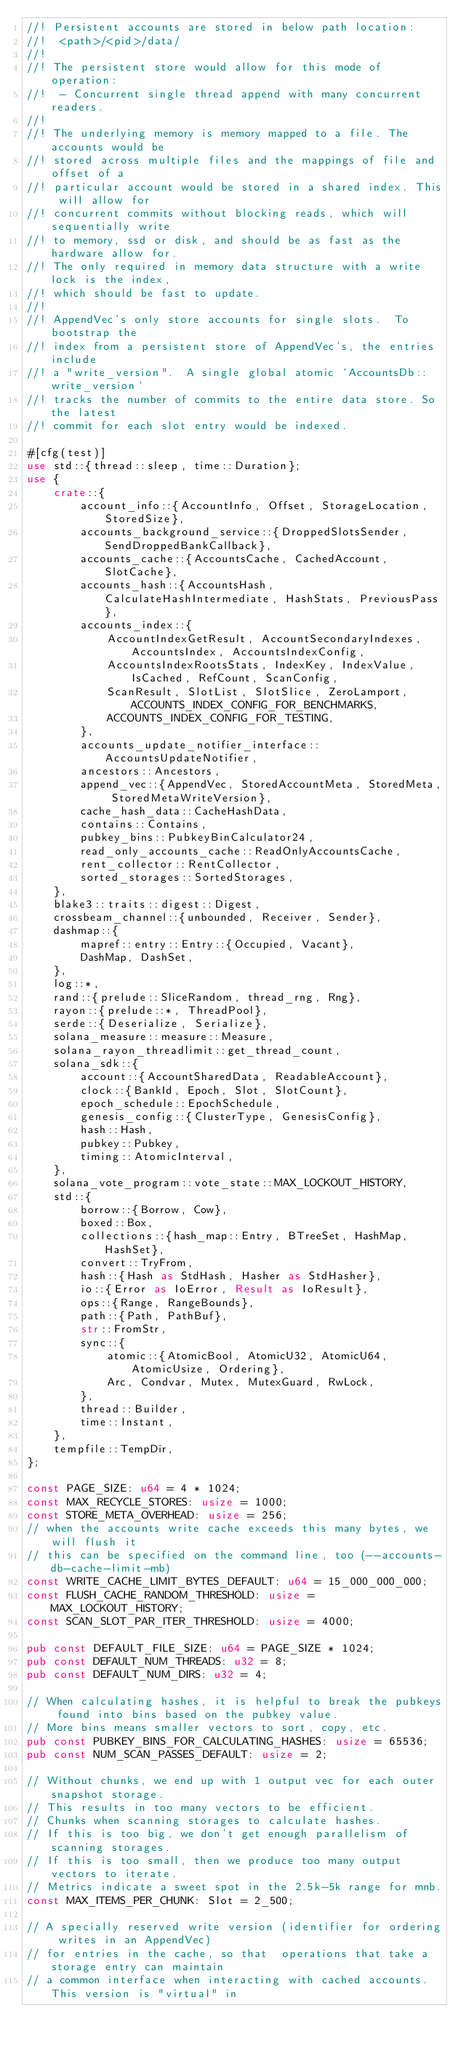<code> <loc_0><loc_0><loc_500><loc_500><_Rust_>//! Persistent accounts are stored in below path location:
//!  <path>/<pid>/data/
//!
//! The persistent store would allow for this mode of operation:
//!  - Concurrent single thread append with many concurrent readers.
//!
//! The underlying memory is memory mapped to a file. The accounts would be
//! stored across multiple files and the mappings of file and offset of a
//! particular account would be stored in a shared index. This will allow for
//! concurrent commits without blocking reads, which will sequentially write
//! to memory, ssd or disk, and should be as fast as the hardware allow for.
//! The only required in memory data structure with a write lock is the index,
//! which should be fast to update.
//!
//! AppendVec's only store accounts for single slots.  To bootstrap the
//! index from a persistent store of AppendVec's, the entries include
//! a "write_version".  A single global atomic `AccountsDb::write_version`
//! tracks the number of commits to the entire data store. So the latest
//! commit for each slot entry would be indexed.

#[cfg(test)]
use std::{thread::sleep, time::Duration};
use {
    crate::{
        account_info::{AccountInfo, Offset, StorageLocation, StoredSize},
        accounts_background_service::{DroppedSlotsSender, SendDroppedBankCallback},
        accounts_cache::{AccountsCache, CachedAccount, SlotCache},
        accounts_hash::{AccountsHash, CalculateHashIntermediate, HashStats, PreviousPass},
        accounts_index::{
            AccountIndexGetResult, AccountSecondaryIndexes, AccountsIndex, AccountsIndexConfig,
            AccountsIndexRootsStats, IndexKey, IndexValue, IsCached, RefCount, ScanConfig,
            ScanResult, SlotList, SlotSlice, ZeroLamport, ACCOUNTS_INDEX_CONFIG_FOR_BENCHMARKS,
            ACCOUNTS_INDEX_CONFIG_FOR_TESTING,
        },
        accounts_update_notifier_interface::AccountsUpdateNotifier,
        ancestors::Ancestors,
        append_vec::{AppendVec, StoredAccountMeta, StoredMeta, StoredMetaWriteVersion},
        cache_hash_data::CacheHashData,
        contains::Contains,
        pubkey_bins::PubkeyBinCalculator24,
        read_only_accounts_cache::ReadOnlyAccountsCache,
        rent_collector::RentCollector,
        sorted_storages::SortedStorages,
    },
    blake3::traits::digest::Digest,
    crossbeam_channel::{unbounded, Receiver, Sender},
    dashmap::{
        mapref::entry::Entry::{Occupied, Vacant},
        DashMap, DashSet,
    },
    log::*,
    rand::{prelude::SliceRandom, thread_rng, Rng},
    rayon::{prelude::*, ThreadPool},
    serde::{Deserialize, Serialize},
    solana_measure::measure::Measure,
    solana_rayon_threadlimit::get_thread_count,
    solana_sdk::{
        account::{AccountSharedData, ReadableAccount},
        clock::{BankId, Epoch, Slot, SlotCount},
        epoch_schedule::EpochSchedule,
        genesis_config::{ClusterType, GenesisConfig},
        hash::Hash,
        pubkey::Pubkey,
        timing::AtomicInterval,
    },
    solana_vote_program::vote_state::MAX_LOCKOUT_HISTORY,
    std::{
        borrow::{Borrow, Cow},
        boxed::Box,
        collections::{hash_map::Entry, BTreeSet, HashMap, HashSet},
        convert::TryFrom,
        hash::{Hash as StdHash, Hasher as StdHasher},
        io::{Error as IoError, Result as IoResult},
        ops::{Range, RangeBounds},
        path::{Path, PathBuf},
        str::FromStr,
        sync::{
            atomic::{AtomicBool, AtomicU32, AtomicU64, AtomicUsize, Ordering},
            Arc, Condvar, Mutex, MutexGuard, RwLock,
        },
        thread::Builder,
        time::Instant,
    },
    tempfile::TempDir,
};

const PAGE_SIZE: u64 = 4 * 1024;
const MAX_RECYCLE_STORES: usize = 1000;
const STORE_META_OVERHEAD: usize = 256;
// when the accounts write cache exceeds this many bytes, we will flush it
// this can be specified on the command line, too (--accounts-db-cache-limit-mb)
const WRITE_CACHE_LIMIT_BYTES_DEFAULT: u64 = 15_000_000_000;
const FLUSH_CACHE_RANDOM_THRESHOLD: usize = MAX_LOCKOUT_HISTORY;
const SCAN_SLOT_PAR_ITER_THRESHOLD: usize = 4000;

pub const DEFAULT_FILE_SIZE: u64 = PAGE_SIZE * 1024;
pub const DEFAULT_NUM_THREADS: u32 = 8;
pub const DEFAULT_NUM_DIRS: u32 = 4;

// When calculating hashes, it is helpful to break the pubkeys found into bins based on the pubkey value.
// More bins means smaller vectors to sort, copy, etc.
pub const PUBKEY_BINS_FOR_CALCULATING_HASHES: usize = 65536;
pub const NUM_SCAN_PASSES_DEFAULT: usize = 2;

// Without chunks, we end up with 1 output vec for each outer snapshot storage.
// This results in too many vectors to be efficient.
// Chunks when scanning storages to calculate hashes.
// If this is too big, we don't get enough parallelism of scanning storages.
// If this is too small, then we produce too many output vectors to iterate.
// Metrics indicate a sweet spot in the 2.5k-5k range for mnb.
const MAX_ITEMS_PER_CHUNK: Slot = 2_500;

// A specially reserved write version (identifier for ordering writes in an AppendVec)
// for entries in the cache, so that  operations that take a storage entry can maintain
// a common interface when interacting with cached accounts. This version is "virtual" in</code> 